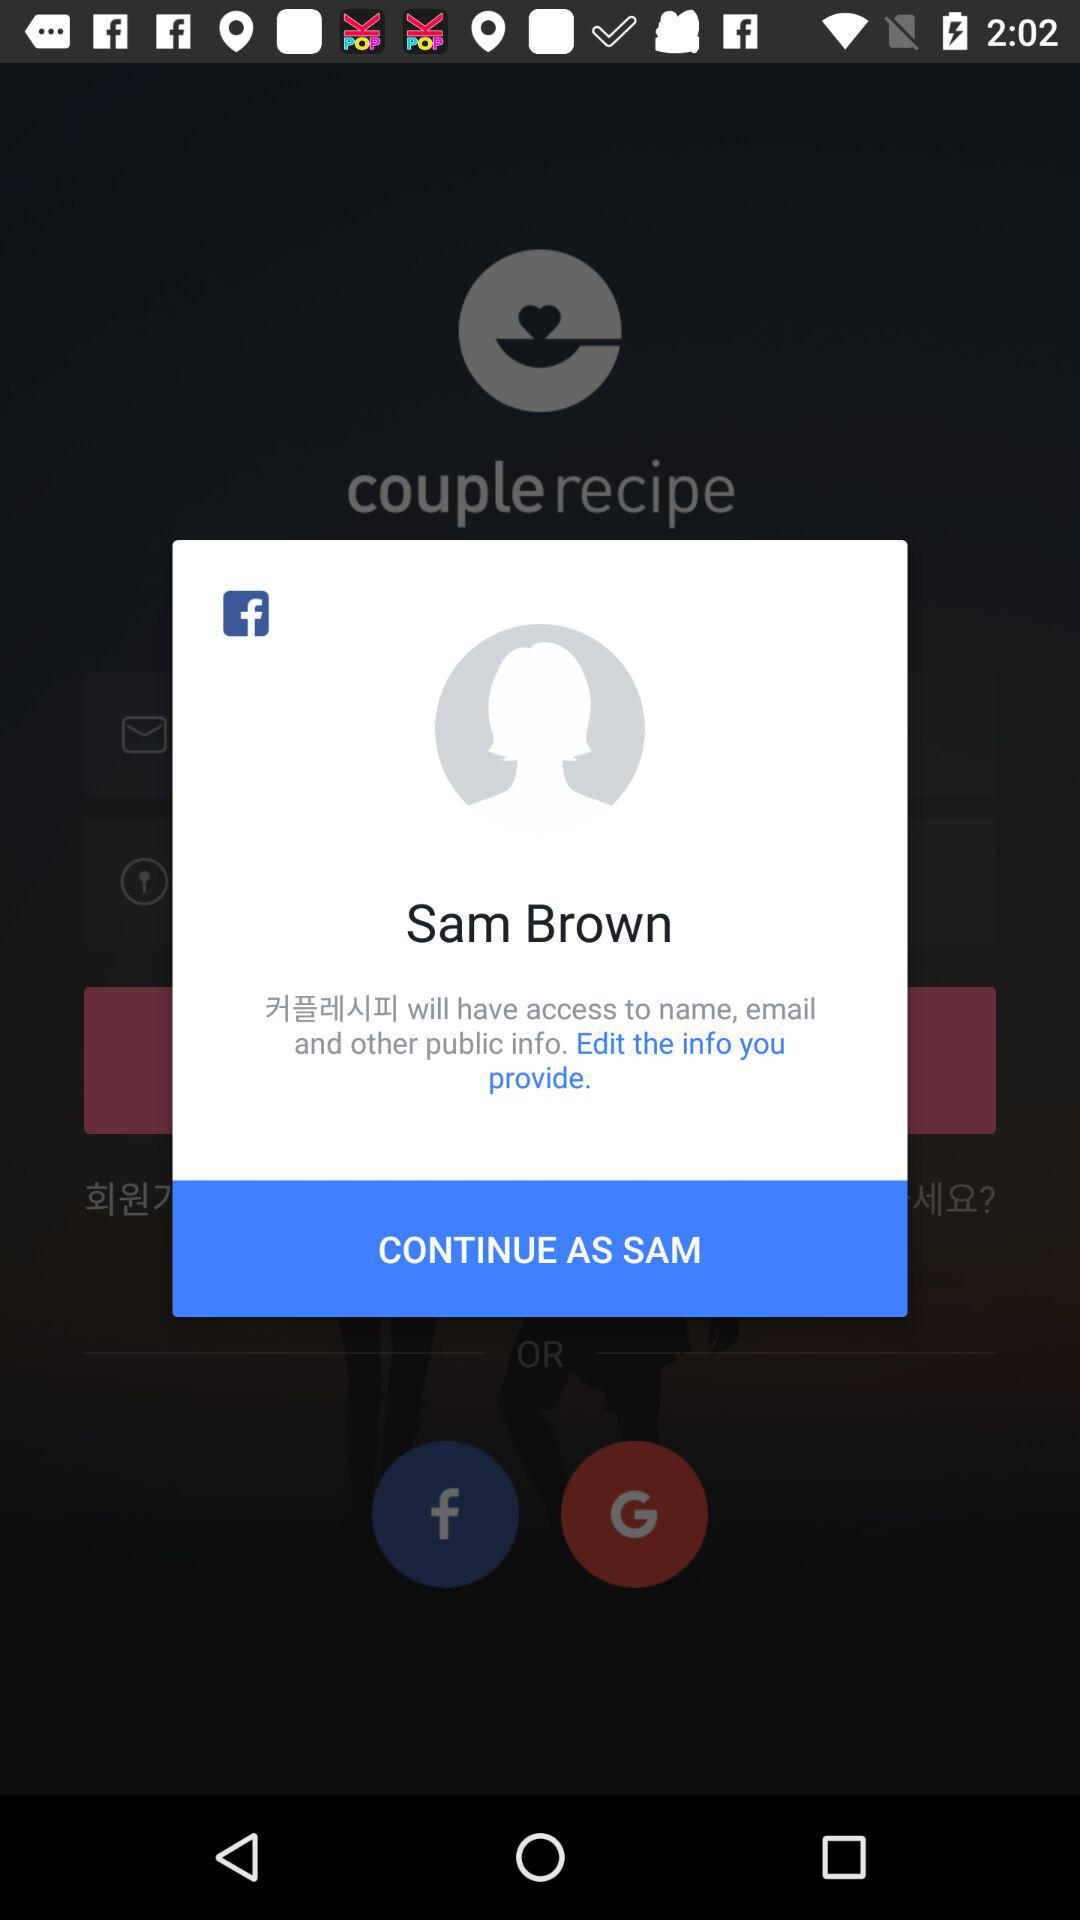What is the login name? The login name is "Sam Brown". 